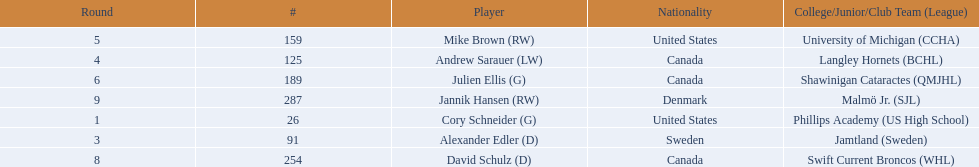Who are the players? Cory Schneider (G), Alexander Edler (D), Andrew Sarauer (LW), Mike Brown (RW), Julien Ellis (G), David Schulz (D), Jannik Hansen (RW). Of those, who is from denmark? Jannik Hansen (RW). 